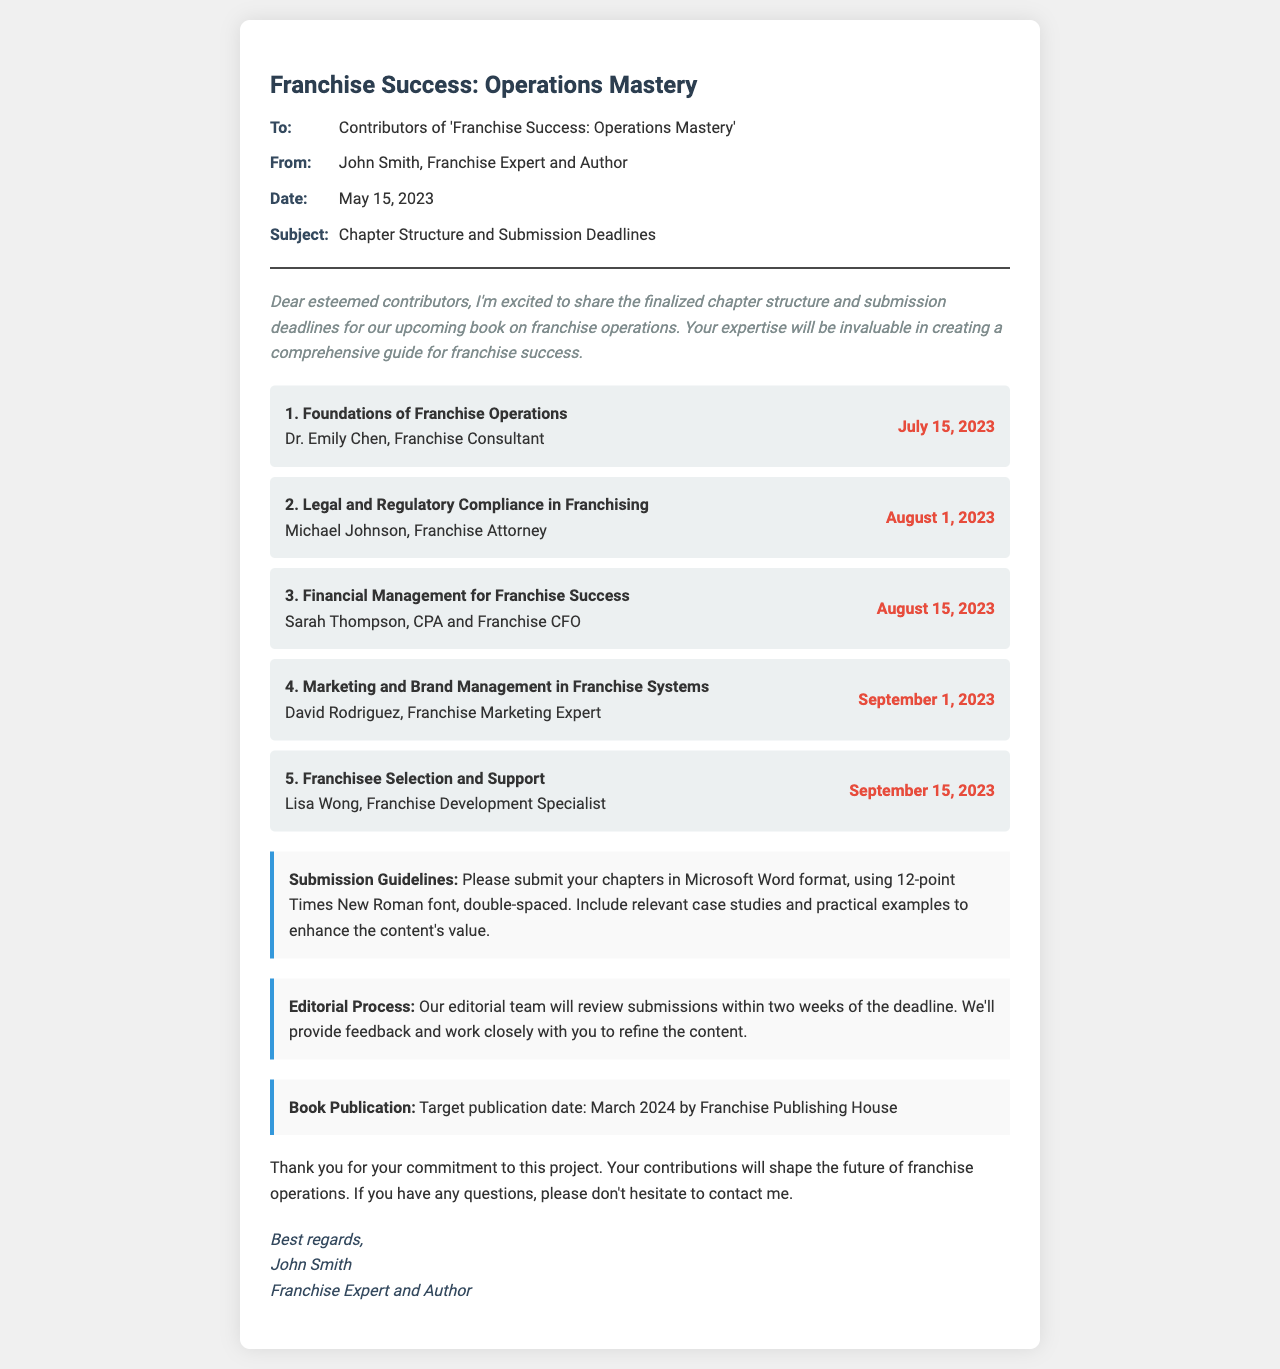What is the title of the book? The title is stated in the header of the document, indicating the focus of the content.
Answer: Franchise Success: Operations Mastery Who is the first chapter author? The document lists the chapter author names along with their respective chapter titles, providing clear attribution.
Answer: Dr. Emily Chen What is the deadline for the second chapter? The deadlines for each chapter are listed next to the chapter titles, indicating submission dates.
Answer: August 1, 2023 How many chapters will be included in the book? The document enumerates the chapters in a list format, giving the total number of chapters.
Answer: Five What format should chapters be submitted in? Submission guidelines specify the required format for the chapters, ensuring consistency.
Answer: Microsoft Word format What is the target publication date for the book? The document mentions the anticipated timeline for publication, which is crucial for contributors to know.
Answer: March 2024 What will the editorial team do after submission? The process section describes the actions of the editorial team, outlining their role in refining the content.
Answer: Review submissions Who is the author of the fax? The fax concludes with a signature line that identifies the sender of the document, providing personal acknowledgment.
Answer: John Smith What type of font should be used in submissions? Submission guidelines include specific formatting instructions for chapters, ensuring clarity and professionalism.
Answer: Times New Roman font 